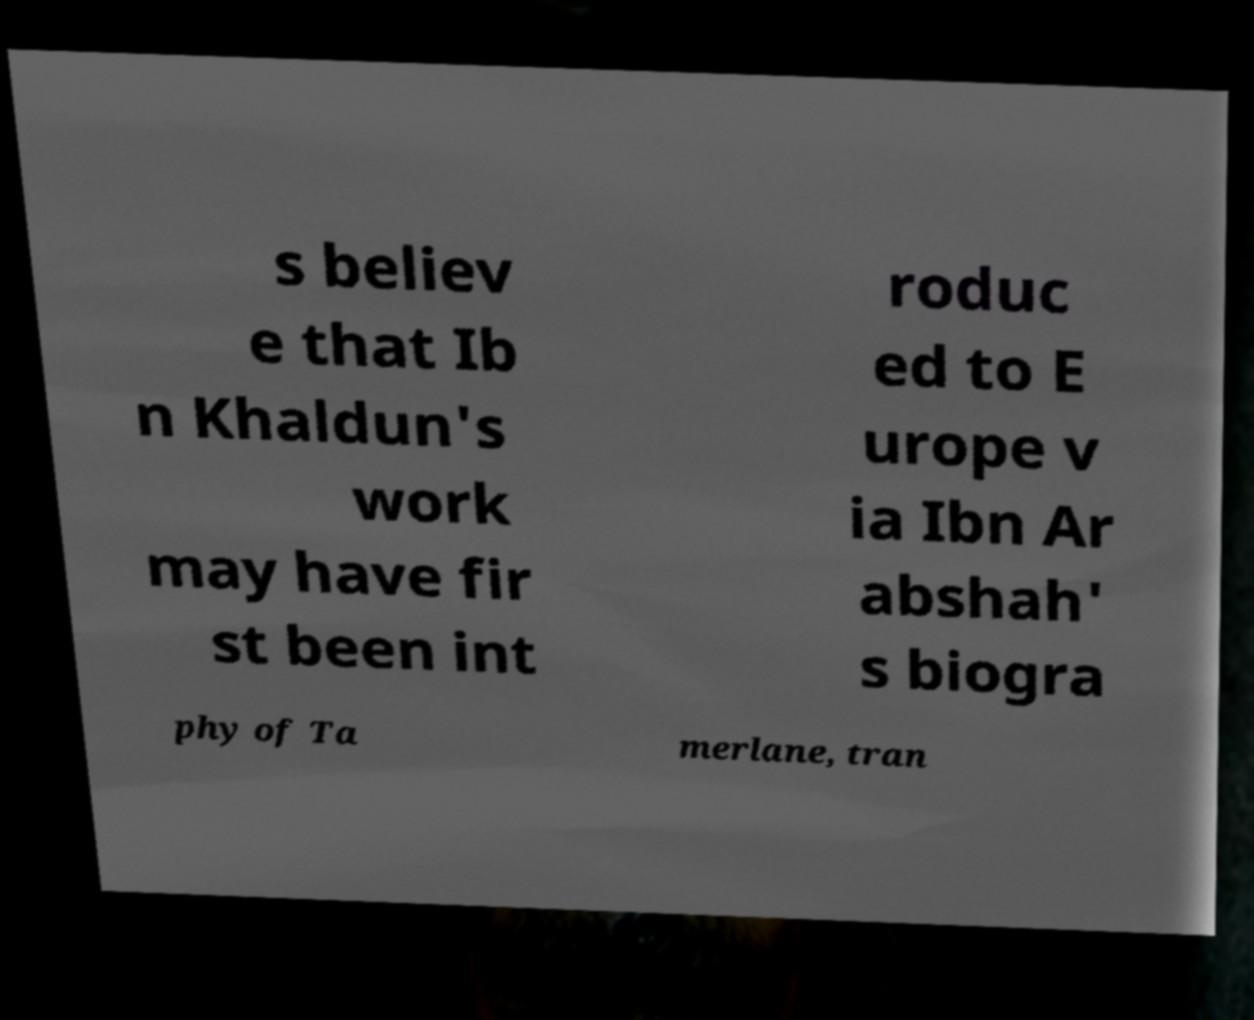I need the written content from this picture converted into text. Can you do that? s believ e that Ib n Khaldun's work may have fir st been int roduc ed to E urope v ia Ibn Ar abshah' s biogra phy of Ta merlane, tran 